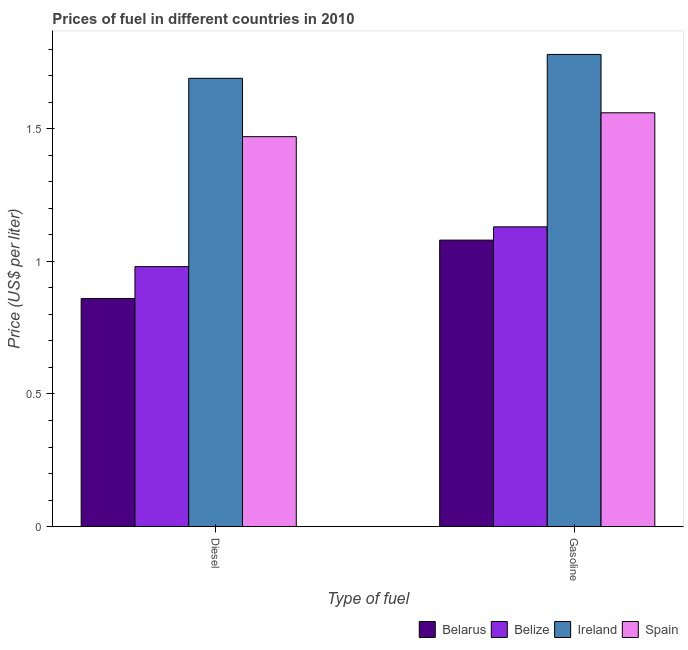How many groups of bars are there?
Provide a succinct answer. 2. How many bars are there on the 1st tick from the right?
Ensure brevity in your answer.  4. What is the label of the 2nd group of bars from the left?
Your response must be concise. Gasoline. What is the gasoline price in Ireland?
Provide a short and direct response. 1.78. Across all countries, what is the maximum diesel price?
Your answer should be very brief. 1.69. Across all countries, what is the minimum diesel price?
Your answer should be compact. 0.86. In which country was the gasoline price maximum?
Provide a succinct answer. Ireland. In which country was the gasoline price minimum?
Your answer should be compact. Belarus. What is the total diesel price in the graph?
Your answer should be compact. 5. What is the difference between the diesel price in Spain and that in Belarus?
Provide a succinct answer. 0.61. What is the difference between the diesel price in Belarus and the gasoline price in Belize?
Ensure brevity in your answer.  -0.27. What is the average diesel price per country?
Provide a succinct answer. 1.25. What is the difference between the diesel price and gasoline price in Belarus?
Offer a very short reply. -0.22. In how many countries, is the diesel price greater than 1.1 US$ per litre?
Make the answer very short. 2. What is the ratio of the diesel price in Belarus to that in Spain?
Offer a very short reply. 0.59. What does the 3rd bar from the left in Gasoline represents?
Give a very brief answer. Ireland. What does the 3rd bar from the right in Gasoline represents?
Give a very brief answer. Belize. How many bars are there?
Offer a very short reply. 8. Are the values on the major ticks of Y-axis written in scientific E-notation?
Give a very brief answer. No. Does the graph contain any zero values?
Give a very brief answer. No. Does the graph contain grids?
Keep it short and to the point. No. How many legend labels are there?
Give a very brief answer. 4. What is the title of the graph?
Offer a terse response. Prices of fuel in different countries in 2010. What is the label or title of the X-axis?
Your response must be concise. Type of fuel. What is the label or title of the Y-axis?
Offer a terse response. Price (US$ per liter). What is the Price (US$ per liter) in Belarus in Diesel?
Keep it short and to the point. 0.86. What is the Price (US$ per liter) of Belize in Diesel?
Ensure brevity in your answer.  0.98. What is the Price (US$ per liter) in Ireland in Diesel?
Give a very brief answer. 1.69. What is the Price (US$ per liter) of Spain in Diesel?
Provide a short and direct response. 1.47. What is the Price (US$ per liter) in Belarus in Gasoline?
Your answer should be compact. 1.08. What is the Price (US$ per liter) of Belize in Gasoline?
Keep it short and to the point. 1.13. What is the Price (US$ per liter) of Ireland in Gasoline?
Give a very brief answer. 1.78. What is the Price (US$ per liter) in Spain in Gasoline?
Offer a terse response. 1.56. Across all Type of fuel, what is the maximum Price (US$ per liter) in Belize?
Offer a terse response. 1.13. Across all Type of fuel, what is the maximum Price (US$ per liter) of Ireland?
Provide a short and direct response. 1.78. Across all Type of fuel, what is the maximum Price (US$ per liter) in Spain?
Your answer should be very brief. 1.56. Across all Type of fuel, what is the minimum Price (US$ per liter) of Belarus?
Your response must be concise. 0.86. Across all Type of fuel, what is the minimum Price (US$ per liter) of Ireland?
Ensure brevity in your answer.  1.69. Across all Type of fuel, what is the minimum Price (US$ per liter) in Spain?
Give a very brief answer. 1.47. What is the total Price (US$ per liter) in Belarus in the graph?
Your answer should be very brief. 1.94. What is the total Price (US$ per liter) in Belize in the graph?
Offer a terse response. 2.11. What is the total Price (US$ per liter) of Ireland in the graph?
Your answer should be very brief. 3.47. What is the total Price (US$ per liter) of Spain in the graph?
Provide a short and direct response. 3.03. What is the difference between the Price (US$ per liter) of Belarus in Diesel and that in Gasoline?
Your response must be concise. -0.22. What is the difference between the Price (US$ per liter) of Ireland in Diesel and that in Gasoline?
Offer a terse response. -0.09. What is the difference between the Price (US$ per liter) in Spain in Diesel and that in Gasoline?
Your answer should be compact. -0.09. What is the difference between the Price (US$ per liter) of Belarus in Diesel and the Price (US$ per liter) of Belize in Gasoline?
Provide a succinct answer. -0.27. What is the difference between the Price (US$ per liter) in Belarus in Diesel and the Price (US$ per liter) in Ireland in Gasoline?
Offer a terse response. -0.92. What is the difference between the Price (US$ per liter) in Belize in Diesel and the Price (US$ per liter) in Spain in Gasoline?
Your answer should be compact. -0.58. What is the difference between the Price (US$ per liter) of Ireland in Diesel and the Price (US$ per liter) of Spain in Gasoline?
Give a very brief answer. 0.13. What is the average Price (US$ per liter) in Belize per Type of fuel?
Your answer should be compact. 1.05. What is the average Price (US$ per liter) in Ireland per Type of fuel?
Your answer should be very brief. 1.74. What is the average Price (US$ per liter) of Spain per Type of fuel?
Keep it short and to the point. 1.51. What is the difference between the Price (US$ per liter) of Belarus and Price (US$ per liter) of Belize in Diesel?
Your answer should be compact. -0.12. What is the difference between the Price (US$ per liter) in Belarus and Price (US$ per liter) in Ireland in Diesel?
Your answer should be very brief. -0.83. What is the difference between the Price (US$ per liter) of Belarus and Price (US$ per liter) of Spain in Diesel?
Keep it short and to the point. -0.61. What is the difference between the Price (US$ per liter) in Belize and Price (US$ per liter) in Ireland in Diesel?
Make the answer very short. -0.71. What is the difference between the Price (US$ per liter) in Belize and Price (US$ per liter) in Spain in Diesel?
Provide a succinct answer. -0.49. What is the difference between the Price (US$ per liter) of Ireland and Price (US$ per liter) of Spain in Diesel?
Your answer should be compact. 0.22. What is the difference between the Price (US$ per liter) in Belarus and Price (US$ per liter) in Belize in Gasoline?
Your response must be concise. -0.05. What is the difference between the Price (US$ per liter) of Belarus and Price (US$ per liter) of Spain in Gasoline?
Offer a very short reply. -0.48. What is the difference between the Price (US$ per liter) in Belize and Price (US$ per liter) in Ireland in Gasoline?
Provide a succinct answer. -0.65. What is the difference between the Price (US$ per liter) in Belize and Price (US$ per liter) in Spain in Gasoline?
Ensure brevity in your answer.  -0.43. What is the difference between the Price (US$ per liter) of Ireland and Price (US$ per liter) of Spain in Gasoline?
Provide a short and direct response. 0.22. What is the ratio of the Price (US$ per liter) of Belarus in Diesel to that in Gasoline?
Keep it short and to the point. 0.8. What is the ratio of the Price (US$ per liter) in Belize in Diesel to that in Gasoline?
Your response must be concise. 0.87. What is the ratio of the Price (US$ per liter) of Ireland in Diesel to that in Gasoline?
Your answer should be compact. 0.95. What is the ratio of the Price (US$ per liter) of Spain in Diesel to that in Gasoline?
Your answer should be compact. 0.94. What is the difference between the highest and the second highest Price (US$ per liter) in Belarus?
Offer a very short reply. 0.22. What is the difference between the highest and the second highest Price (US$ per liter) of Belize?
Your response must be concise. 0.15. What is the difference between the highest and the second highest Price (US$ per liter) of Ireland?
Give a very brief answer. 0.09. What is the difference between the highest and the second highest Price (US$ per liter) in Spain?
Make the answer very short. 0.09. What is the difference between the highest and the lowest Price (US$ per liter) of Belarus?
Your answer should be very brief. 0.22. What is the difference between the highest and the lowest Price (US$ per liter) in Ireland?
Offer a terse response. 0.09. What is the difference between the highest and the lowest Price (US$ per liter) in Spain?
Ensure brevity in your answer.  0.09. 